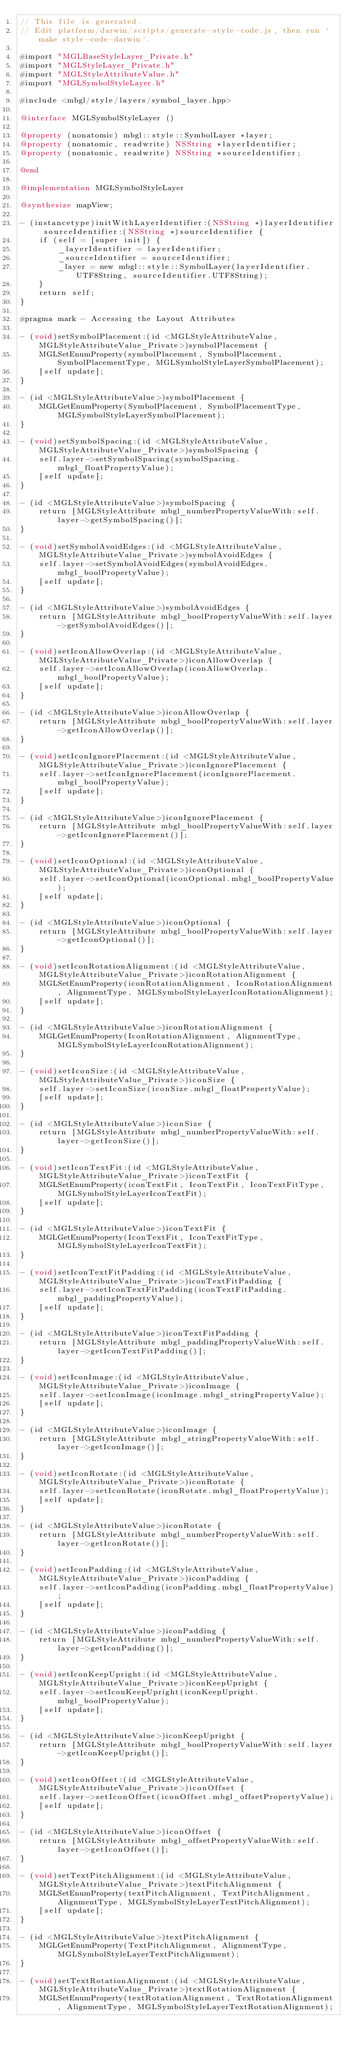Convert code to text. <code><loc_0><loc_0><loc_500><loc_500><_ObjectiveC_>// This file is generated. 
// Edit platform/darwin/scripts/generate-style-code.js, then run `make style-code-darwin`.

#import "MGLBaseStyleLayer_Private.h"
#import "MGLStyleLayer_Private.h"
#import "MGLStyleAttributeValue.h"
#import "MGLSymbolStyleLayer.h"

#include <mbgl/style/layers/symbol_layer.hpp>

@interface MGLSymbolStyleLayer ()

@property (nonatomic) mbgl::style::SymbolLayer *layer;
@property (nonatomic, readwrite) NSString *layerIdentifier;
@property (nonatomic, readwrite) NSString *sourceIdentifier;

@end

@implementation MGLSymbolStyleLayer

@synthesize mapView;

- (instancetype)initWithLayerIdentifier:(NSString *)layerIdentifier sourceIdentifier:(NSString *)sourceIdentifier {
    if (self = [super init]) {
        _layerIdentifier = layerIdentifier;
        _sourceIdentifier = sourceIdentifier;
        _layer = new mbgl::style::SymbolLayer(layerIdentifier.UTF8String, sourceIdentifier.UTF8String);
    }
    return self;
}

#pragma mark - Accessing the Layout Attributes

- (void)setSymbolPlacement:(id <MGLStyleAttributeValue, MGLStyleAttributeValue_Private>)symbolPlacement {
    MGLSetEnumProperty(symbolPlacement, SymbolPlacement, SymbolPlacementType, MGLSymbolStyleLayerSymbolPlacement);
    [self update];
}

- (id <MGLStyleAttributeValue>)symbolPlacement {
    MGLGetEnumProperty(SymbolPlacement, SymbolPlacementType, MGLSymbolStyleLayerSymbolPlacement);
}

- (void)setSymbolSpacing:(id <MGLStyleAttributeValue, MGLStyleAttributeValue_Private>)symbolSpacing {
    self.layer->setSymbolSpacing(symbolSpacing.mbgl_floatPropertyValue);
    [self update];
}

- (id <MGLStyleAttributeValue>)symbolSpacing {
    return [MGLStyleAttribute mbgl_numberPropertyValueWith:self.layer->getSymbolSpacing()];
}

- (void)setSymbolAvoidEdges:(id <MGLStyleAttributeValue, MGLStyleAttributeValue_Private>)symbolAvoidEdges {
    self.layer->setSymbolAvoidEdges(symbolAvoidEdges.mbgl_boolPropertyValue);
    [self update];
}

- (id <MGLStyleAttributeValue>)symbolAvoidEdges {
    return [MGLStyleAttribute mbgl_boolPropertyValueWith:self.layer->getSymbolAvoidEdges()];
}

- (void)setIconAllowOverlap:(id <MGLStyleAttributeValue, MGLStyleAttributeValue_Private>)iconAllowOverlap {
    self.layer->setIconAllowOverlap(iconAllowOverlap.mbgl_boolPropertyValue);
    [self update];
}

- (id <MGLStyleAttributeValue>)iconAllowOverlap {
    return [MGLStyleAttribute mbgl_boolPropertyValueWith:self.layer->getIconAllowOverlap()];
}

- (void)setIconIgnorePlacement:(id <MGLStyleAttributeValue, MGLStyleAttributeValue_Private>)iconIgnorePlacement {
    self.layer->setIconIgnorePlacement(iconIgnorePlacement.mbgl_boolPropertyValue);
    [self update];
}

- (id <MGLStyleAttributeValue>)iconIgnorePlacement {
    return [MGLStyleAttribute mbgl_boolPropertyValueWith:self.layer->getIconIgnorePlacement()];
}

- (void)setIconOptional:(id <MGLStyleAttributeValue, MGLStyleAttributeValue_Private>)iconOptional {
    self.layer->setIconOptional(iconOptional.mbgl_boolPropertyValue);
    [self update];
}

- (id <MGLStyleAttributeValue>)iconOptional {
    return [MGLStyleAttribute mbgl_boolPropertyValueWith:self.layer->getIconOptional()];
}

- (void)setIconRotationAlignment:(id <MGLStyleAttributeValue, MGLStyleAttributeValue_Private>)iconRotationAlignment {
    MGLSetEnumProperty(iconRotationAlignment, IconRotationAlignment, AlignmentType, MGLSymbolStyleLayerIconRotationAlignment);
    [self update];
}

- (id <MGLStyleAttributeValue>)iconRotationAlignment {
    MGLGetEnumProperty(IconRotationAlignment, AlignmentType, MGLSymbolStyleLayerIconRotationAlignment);
}

- (void)setIconSize:(id <MGLStyleAttributeValue, MGLStyleAttributeValue_Private>)iconSize {
    self.layer->setIconSize(iconSize.mbgl_floatPropertyValue);
    [self update];
}

- (id <MGLStyleAttributeValue>)iconSize {
    return [MGLStyleAttribute mbgl_numberPropertyValueWith:self.layer->getIconSize()];
}

- (void)setIconTextFit:(id <MGLStyleAttributeValue, MGLStyleAttributeValue_Private>)iconTextFit {
    MGLSetEnumProperty(iconTextFit, IconTextFit, IconTextFitType, MGLSymbolStyleLayerIconTextFit);
    [self update];
}

- (id <MGLStyleAttributeValue>)iconTextFit {
    MGLGetEnumProperty(IconTextFit, IconTextFitType, MGLSymbolStyleLayerIconTextFit);
}

- (void)setIconTextFitPadding:(id <MGLStyleAttributeValue, MGLStyleAttributeValue_Private>)iconTextFitPadding {
    self.layer->setIconTextFitPadding(iconTextFitPadding.mbgl_paddingPropertyValue);
    [self update];
}

- (id <MGLStyleAttributeValue>)iconTextFitPadding {
    return [MGLStyleAttribute mbgl_paddingPropertyValueWith:self.layer->getIconTextFitPadding()];
}

- (void)setIconImage:(id <MGLStyleAttributeValue, MGLStyleAttributeValue_Private>)iconImage {
    self.layer->setIconImage(iconImage.mbgl_stringPropertyValue);
    [self update];
}

- (id <MGLStyleAttributeValue>)iconImage {
    return [MGLStyleAttribute mbgl_stringPropertyValueWith:self.layer->getIconImage()];
}

- (void)setIconRotate:(id <MGLStyleAttributeValue, MGLStyleAttributeValue_Private>)iconRotate {
    self.layer->setIconRotate(iconRotate.mbgl_floatPropertyValue);
    [self update];
}

- (id <MGLStyleAttributeValue>)iconRotate {
    return [MGLStyleAttribute mbgl_numberPropertyValueWith:self.layer->getIconRotate()];
}

- (void)setIconPadding:(id <MGLStyleAttributeValue, MGLStyleAttributeValue_Private>)iconPadding {
    self.layer->setIconPadding(iconPadding.mbgl_floatPropertyValue);
    [self update];
}

- (id <MGLStyleAttributeValue>)iconPadding {
    return [MGLStyleAttribute mbgl_numberPropertyValueWith:self.layer->getIconPadding()];
}

- (void)setIconKeepUpright:(id <MGLStyleAttributeValue, MGLStyleAttributeValue_Private>)iconKeepUpright {
    self.layer->setIconKeepUpright(iconKeepUpright.mbgl_boolPropertyValue);
    [self update];
}

- (id <MGLStyleAttributeValue>)iconKeepUpright {
    return [MGLStyleAttribute mbgl_boolPropertyValueWith:self.layer->getIconKeepUpright()];
}

- (void)setIconOffset:(id <MGLStyleAttributeValue, MGLStyleAttributeValue_Private>)iconOffset {
    self.layer->setIconOffset(iconOffset.mbgl_offsetPropertyValue);
    [self update];
}

- (id <MGLStyleAttributeValue>)iconOffset {
    return [MGLStyleAttribute mbgl_offsetPropertyValueWith:self.layer->getIconOffset()];
}

- (void)setTextPitchAlignment:(id <MGLStyleAttributeValue, MGLStyleAttributeValue_Private>)textPitchAlignment {
    MGLSetEnumProperty(textPitchAlignment, TextPitchAlignment, AlignmentType, MGLSymbolStyleLayerTextPitchAlignment);
    [self update];
}

- (id <MGLStyleAttributeValue>)textPitchAlignment {
    MGLGetEnumProperty(TextPitchAlignment, AlignmentType, MGLSymbolStyleLayerTextPitchAlignment);
}

- (void)setTextRotationAlignment:(id <MGLStyleAttributeValue, MGLStyleAttributeValue_Private>)textRotationAlignment {
    MGLSetEnumProperty(textRotationAlignment, TextRotationAlignment, AlignmentType, MGLSymbolStyleLayerTextRotationAlignment);</code> 